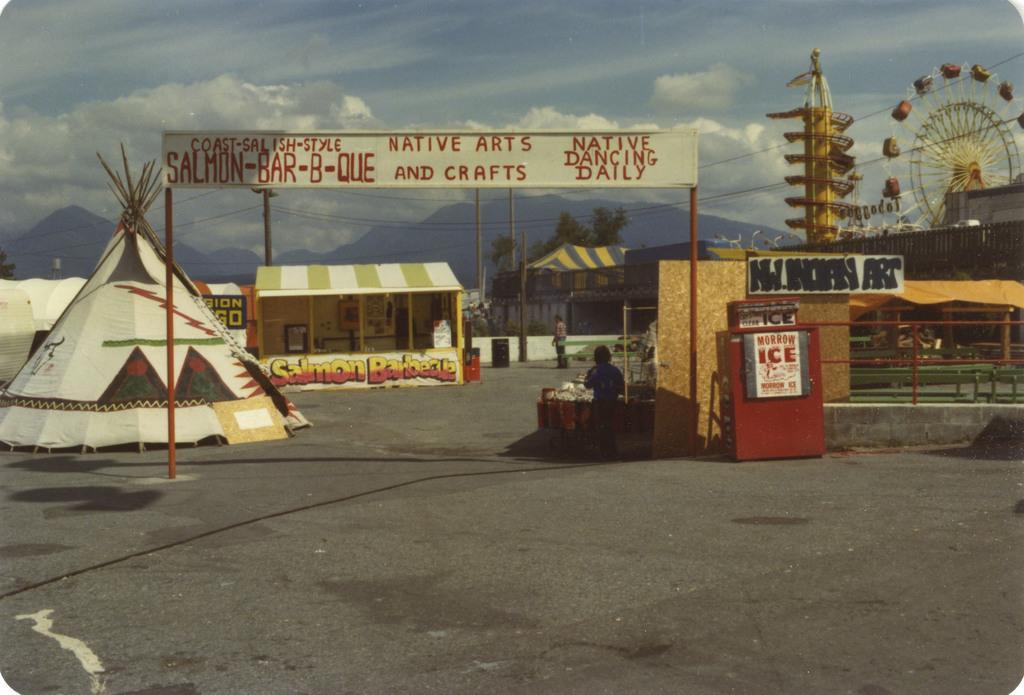Describe this image in one or two sentences. In the image it looks like some exhibition park, there is a board at the entrance and inside that there are some tents, stalls and amusement rides. 